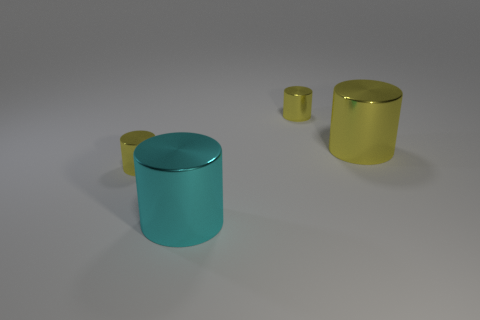There is a cyan shiny thing that is the same shape as the large yellow shiny thing; what is its size?
Make the answer very short. Large. The cyan object has what size?
Your answer should be compact. Large. Are there fewer large cyan metal cylinders that are behind the large yellow metal thing than cyan objects?
Ensure brevity in your answer.  Yes. Is there anything else that has the same size as the cyan metallic cylinder?
Ensure brevity in your answer.  Yes. What color is the other big cylinder that is the same material as the big yellow cylinder?
Offer a terse response. Cyan. Is the number of large cyan shiny things that are in front of the cyan thing less than the number of yellow shiny cylinders to the right of the big yellow shiny cylinder?
Provide a short and direct response. No. What number of tiny shiny cylinders are on the right side of the big cyan shiny cylinder and on the left side of the large cyan object?
Offer a very short reply. 0. The small yellow thing behind the tiny yellow cylinder left of the cyan cylinder is made of what material?
Your answer should be very brief. Metal. Are there any tiny yellow cylinders that have the same material as the cyan object?
Provide a succinct answer. Yes. What material is the cylinder that is the same size as the cyan thing?
Provide a succinct answer. Metal. 